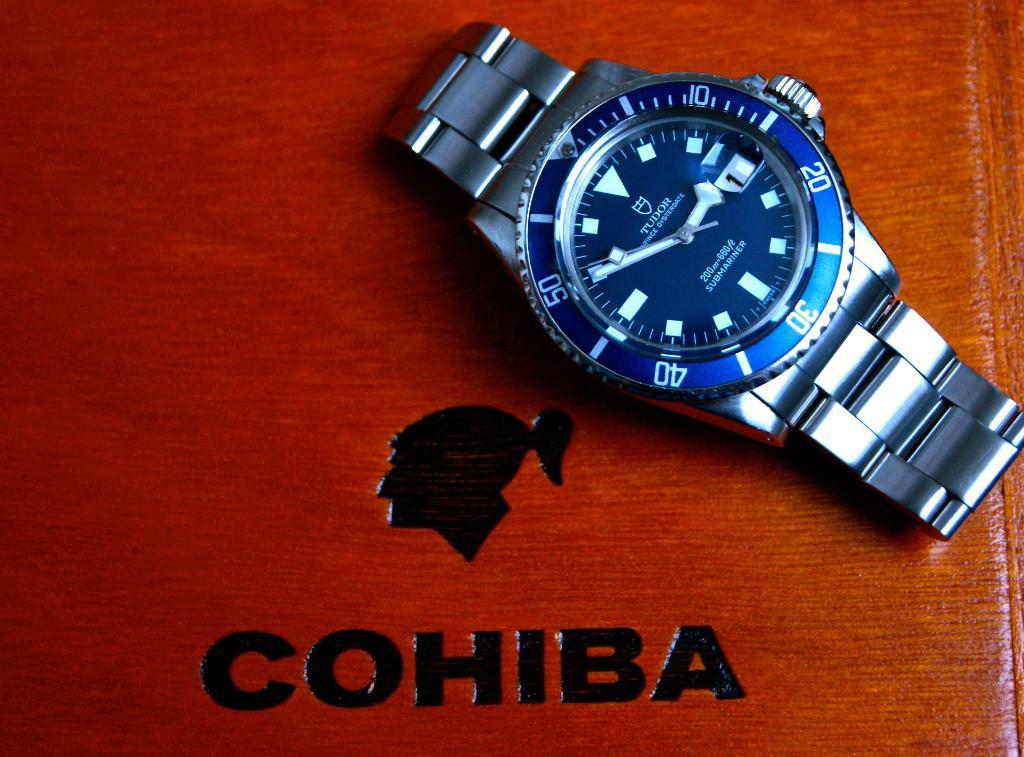<image>
Provide a brief description of the given image. A TUDOR SUBMARINER watch is on a brown surface that says COHIBA. 